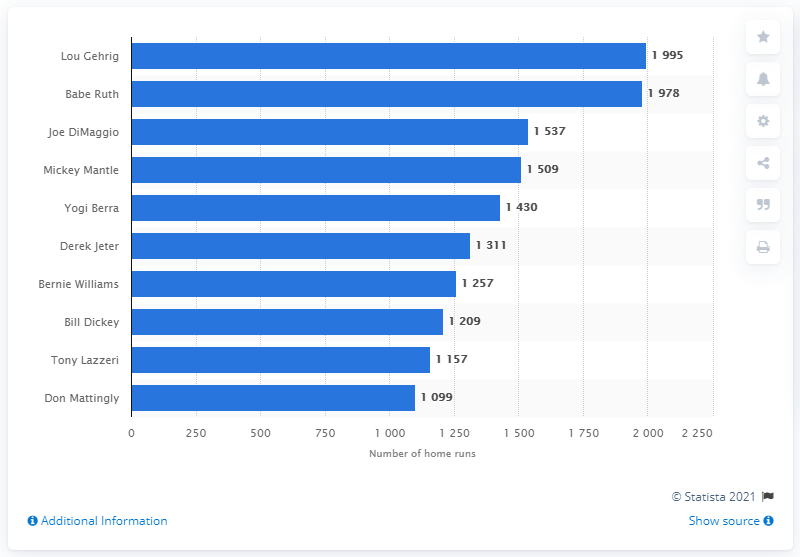Highlight a few significant elements in this photo. The New York Yankees franchise record for most RBIs belongs to Lou Gehrig, with a total of (insert number of RBIs). 